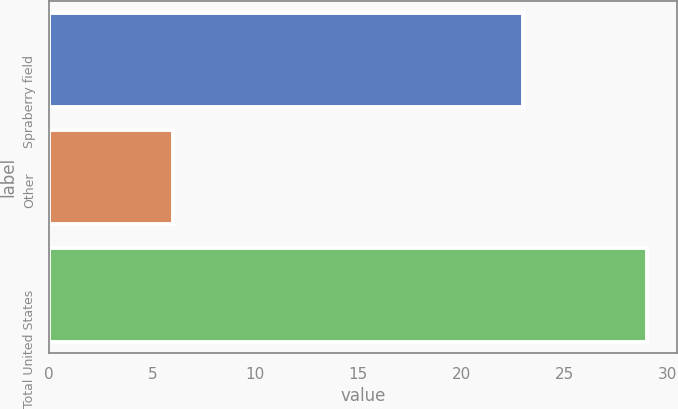<chart> <loc_0><loc_0><loc_500><loc_500><bar_chart><fcel>Spraberry field<fcel>Other<fcel>Total United States<nl><fcel>23<fcel>6<fcel>29<nl></chart> 